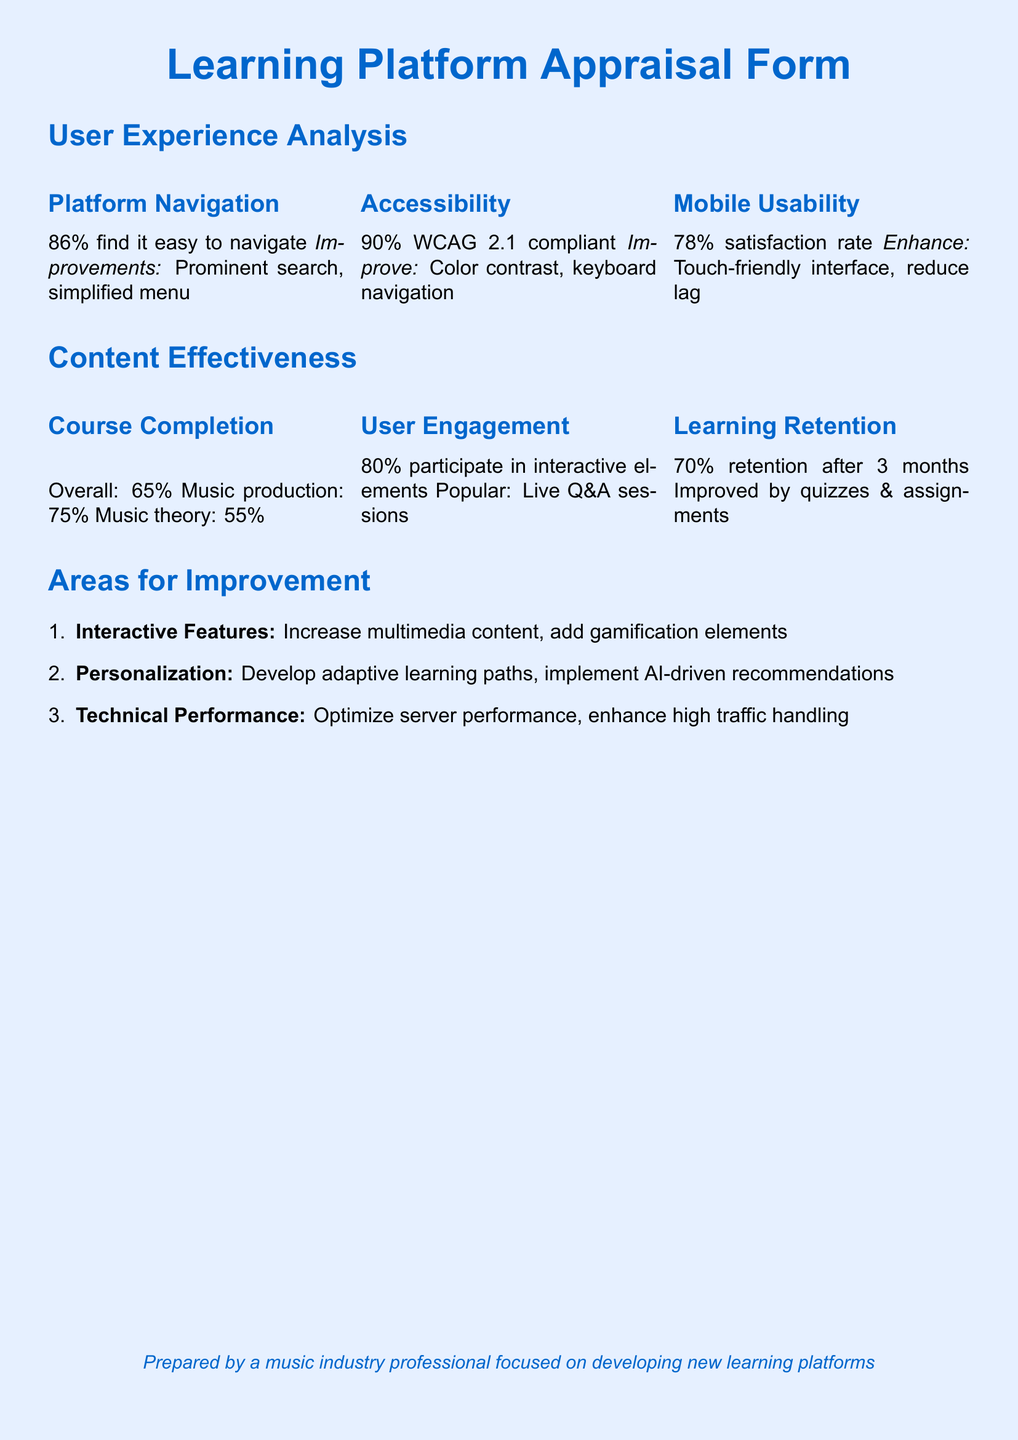what percentage of users find it easy to navigate the platform? The document states that 86% of users find it easy to navigate the platform.
Answer: 86% what is the course completion rate for music theory? The completion rate for music theory is indicated in the document as 55%.
Answer: 55% what percentage of users are satisfied with mobile usability? According to the document, 78% of users are satisfied with mobile usability.
Answer: 78% what interactive feature is noted to be popular among users? The document highlights live Q&A sessions as a popular interactive feature among users.
Answer: Live Q&A sessions what area for improvement is related to technical performance? The improvement noted in the document related to technical performance is to optimize server performance.
Answer: Optimize server performance what is the user engagement percentage for participating in interactive elements? The document specifies that 80% of users participate in interactive elements.
Answer: 80% what is the overall course completion rate mentioned in the document? The overall course completion rate is provided as 65% in the document.
Answer: 65% which compliance standard does the platform meet? The platform is compliant with WCAG 2.1 as stated in the document.
Answer: WCAG 2.1 what improvement is suggested for accessibility? The document suggests improving color contrast as an enhancement for accessibility.
Answer: Color contrast 